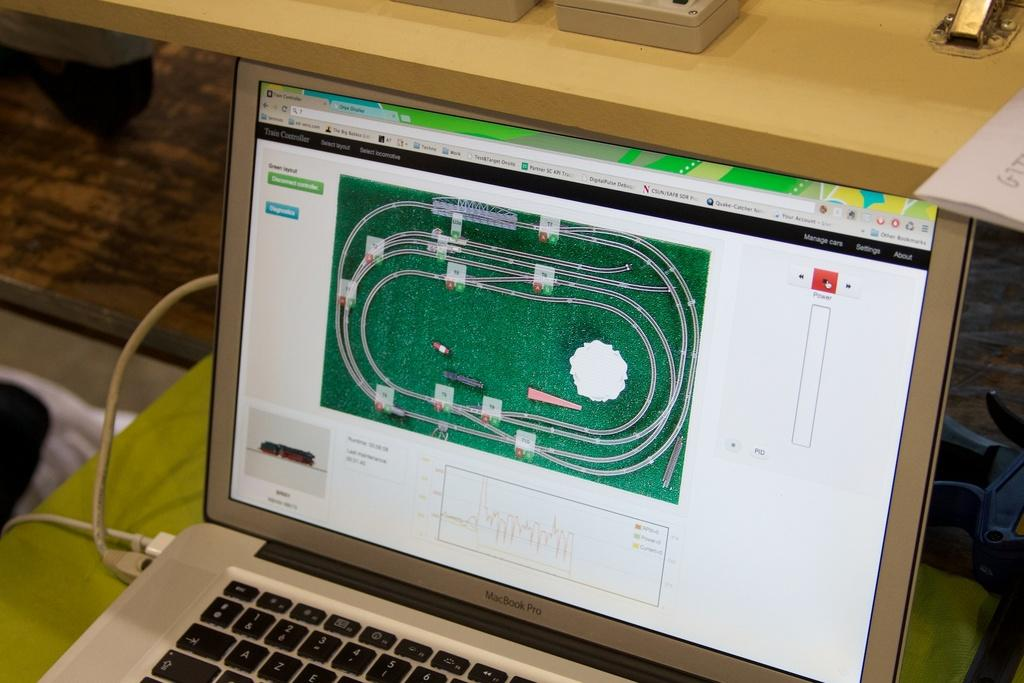What is connected to the cables in the image? There are cables connected to a laptop in the image. Can you describe the setting in which the laptop is located? There is a table in the background of the image. How many dolls are sitting on the camera in the image? There is no camera or dolls present in the image. 